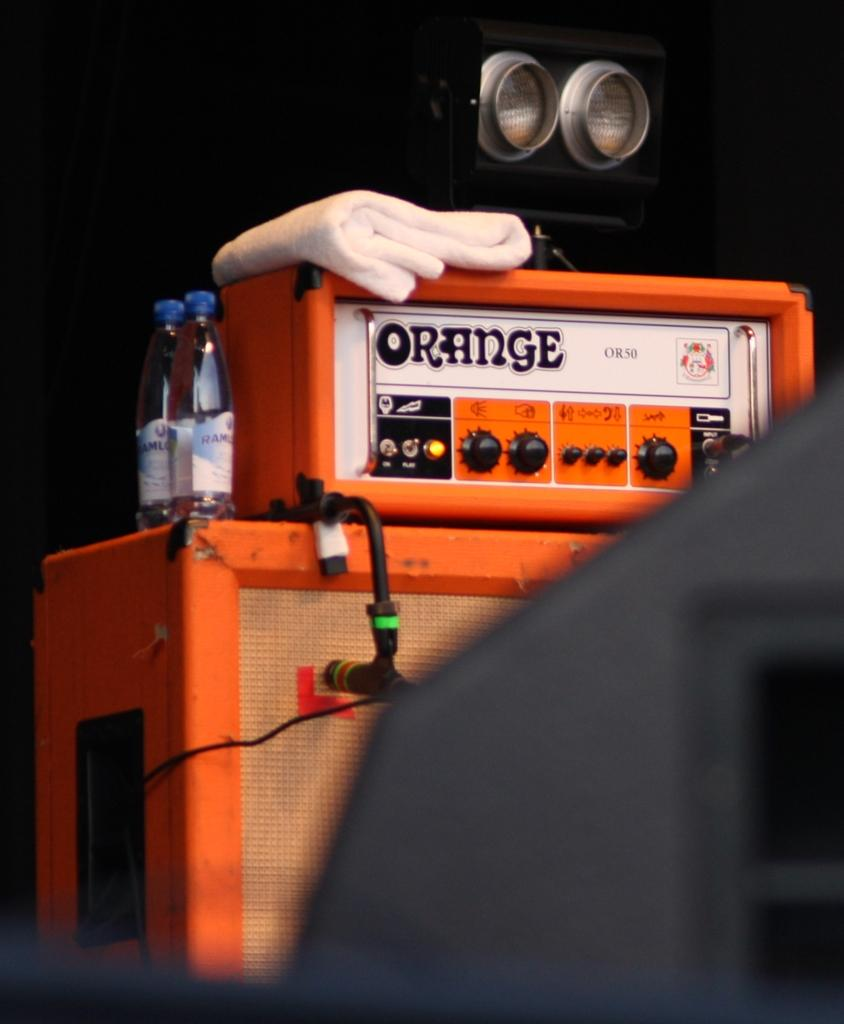Provide a one-sentence caption for the provided image. A machine with Orange written on it is orange with gloves on top. 